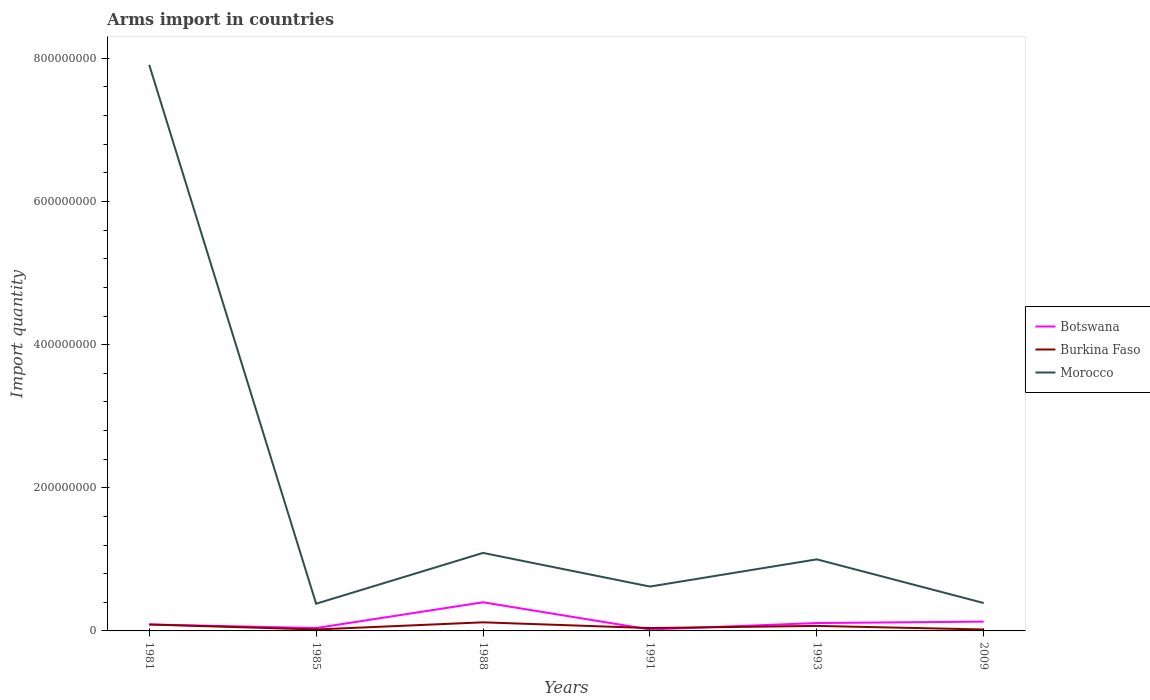How many different coloured lines are there?
Your answer should be very brief. 3. Across all years, what is the maximum total arms import in Botswana?
Keep it short and to the point. 2.00e+06. Is the total arms import in Morocco strictly greater than the total arms import in Botswana over the years?
Provide a short and direct response. No. How many lines are there?
Provide a succinct answer. 3. How many years are there in the graph?
Offer a terse response. 6. What is the difference between two consecutive major ticks on the Y-axis?
Offer a terse response. 2.00e+08. Where does the legend appear in the graph?
Offer a terse response. Center right. What is the title of the graph?
Your answer should be very brief. Arms import in countries. Does "Congo (Republic)" appear as one of the legend labels in the graph?
Give a very brief answer. No. What is the label or title of the Y-axis?
Keep it short and to the point. Import quantity. What is the Import quantity of Botswana in 1981?
Your answer should be very brief. 9.00e+06. What is the Import quantity in Burkina Faso in 1981?
Your answer should be compact. 9.00e+06. What is the Import quantity of Morocco in 1981?
Your answer should be compact. 7.91e+08. What is the Import quantity of Burkina Faso in 1985?
Provide a succinct answer. 2.00e+06. What is the Import quantity in Morocco in 1985?
Ensure brevity in your answer.  3.80e+07. What is the Import quantity of Botswana in 1988?
Your answer should be very brief. 4.00e+07. What is the Import quantity in Burkina Faso in 1988?
Give a very brief answer. 1.20e+07. What is the Import quantity in Morocco in 1988?
Provide a short and direct response. 1.09e+08. What is the Import quantity in Botswana in 1991?
Provide a succinct answer. 2.00e+06. What is the Import quantity in Burkina Faso in 1991?
Keep it short and to the point. 4.00e+06. What is the Import quantity in Morocco in 1991?
Your answer should be compact. 6.20e+07. What is the Import quantity in Botswana in 1993?
Give a very brief answer. 1.10e+07. What is the Import quantity of Burkina Faso in 1993?
Make the answer very short. 7.00e+06. What is the Import quantity in Morocco in 1993?
Provide a succinct answer. 1.00e+08. What is the Import quantity of Botswana in 2009?
Your response must be concise. 1.30e+07. What is the Import quantity in Burkina Faso in 2009?
Your response must be concise. 2.00e+06. What is the Import quantity in Morocco in 2009?
Your answer should be very brief. 3.90e+07. Across all years, what is the maximum Import quantity of Botswana?
Your answer should be very brief. 4.00e+07. Across all years, what is the maximum Import quantity of Morocco?
Offer a very short reply. 7.91e+08. Across all years, what is the minimum Import quantity in Botswana?
Keep it short and to the point. 2.00e+06. Across all years, what is the minimum Import quantity of Burkina Faso?
Offer a terse response. 2.00e+06. Across all years, what is the minimum Import quantity of Morocco?
Your response must be concise. 3.80e+07. What is the total Import quantity of Botswana in the graph?
Make the answer very short. 7.90e+07. What is the total Import quantity in Burkina Faso in the graph?
Make the answer very short. 3.60e+07. What is the total Import quantity of Morocco in the graph?
Provide a short and direct response. 1.14e+09. What is the difference between the Import quantity in Botswana in 1981 and that in 1985?
Ensure brevity in your answer.  5.00e+06. What is the difference between the Import quantity of Burkina Faso in 1981 and that in 1985?
Provide a short and direct response. 7.00e+06. What is the difference between the Import quantity in Morocco in 1981 and that in 1985?
Your answer should be compact. 7.53e+08. What is the difference between the Import quantity in Botswana in 1981 and that in 1988?
Your response must be concise. -3.10e+07. What is the difference between the Import quantity in Morocco in 1981 and that in 1988?
Provide a succinct answer. 6.82e+08. What is the difference between the Import quantity of Botswana in 1981 and that in 1991?
Your response must be concise. 7.00e+06. What is the difference between the Import quantity of Burkina Faso in 1981 and that in 1991?
Offer a terse response. 5.00e+06. What is the difference between the Import quantity in Morocco in 1981 and that in 1991?
Offer a very short reply. 7.29e+08. What is the difference between the Import quantity in Botswana in 1981 and that in 1993?
Give a very brief answer. -2.00e+06. What is the difference between the Import quantity of Morocco in 1981 and that in 1993?
Keep it short and to the point. 6.91e+08. What is the difference between the Import quantity in Burkina Faso in 1981 and that in 2009?
Your response must be concise. 7.00e+06. What is the difference between the Import quantity of Morocco in 1981 and that in 2009?
Keep it short and to the point. 7.52e+08. What is the difference between the Import quantity of Botswana in 1985 and that in 1988?
Ensure brevity in your answer.  -3.60e+07. What is the difference between the Import quantity of Burkina Faso in 1985 and that in 1988?
Offer a very short reply. -1.00e+07. What is the difference between the Import quantity in Morocco in 1985 and that in 1988?
Keep it short and to the point. -7.10e+07. What is the difference between the Import quantity of Botswana in 1985 and that in 1991?
Your response must be concise. 2.00e+06. What is the difference between the Import quantity of Burkina Faso in 1985 and that in 1991?
Your response must be concise. -2.00e+06. What is the difference between the Import quantity in Morocco in 1985 and that in 1991?
Your answer should be very brief. -2.40e+07. What is the difference between the Import quantity in Botswana in 1985 and that in 1993?
Provide a short and direct response. -7.00e+06. What is the difference between the Import quantity of Burkina Faso in 1985 and that in 1993?
Your answer should be compact. -5.00e+06. What is the difference between the Import quantity in Morocco in 1985 and that in 1993?
Give a very brief answer. -6.20e+07. What is the difference between the Import quantity of Botswana in 1985 and that in 2009?
Offer a terse response. -9.00e+06. What is the difference between the Import quantity of Morocco in 1985 and that in 2009?
Ensure brevity in your answer.  -1.00e+06. What is the difference between the Import quantity in Botswana in 1988 and that in 1991?
Make the answer very short. 3.80e+07. What is the difference between the Import quantity of Morocco in 1988 and that in 1991?
Offer a terse response. 4.70e+07. What is the difference between the Import quantity in Botswana in 1988 and that in 1993?
Your response must be concise. 2.90e+07. What is the difference between the Import quantity of Burkina Faso in 1988 and that in 1993?
Provide a short and direct response. 5.00e+06. What is the difference between the Import quantity in Morocco in 1988 and that in 1993?
Ensure brevity in your answer.  9.00e+06. What is the difference between the Import quantity of Botswana in 1988 and that in 2009?
Your answer should be compact. 2.70e+07. What is the difference between the Import quantity of Burkina Faso in 1988 and that in 2009?
Your response must be concise. 1.00e+07. What is the difference between the Import quantity of Morocco in 1988 and that in 2009?
Make the answer very short. 7.00e+07. What is the difference between the Import quantity of Botswana in 1991 and that in 1993?
Your response must be concise. -9.00e+06. What is the difference between the Import quantity of Morocco in 1991 and that in 1993?
Your response must be concise. -3.80e+07. What is the difference between the Import quantity in Botswana in 1991 and that in 2009?
Your response must be concise. -1.10e+07. What is the difference between the Import quantity in Burkina Faso in 1991 and that in 2009?
Provide a short and direct response. 2.00e+06. What is the difference between the Import quantity of Morocco in 1991 and that in 2009?
Your answer should be compact. 2.30e+07. What is the difference between the Import quantity of Burkina Faso in 1993 and that in 2009?
Your answer should be compact. 5.00e+06. What is the difference between the Import quantity of Morocco in 1993 and that in 2009?
Keep it short and to the point. 6.10e+07. What is the difference between the Import quantity in Botswana in 1981 and the Import quantity in Burkina Faso in 1985?
Keep it short and to the point. 7.00e+06. What is the difference between the Import quantity in Botswana in 1981 and the Import quantity in Morocco in 1985?
Your answer should be compact. -2.90e+07. What is the difference between the Import quantity in Burkina Faso in 1981 and the Import quantity in Morocco in 1985?
Provide a succinct answer. -2.90e+07. What is the difference between the Import quantity in Botswana in 1981 and the Import quantity in Burkina Faso in 1988?
Give a very brief answer. -3.00e+06. What is the difference between the Import quantity of Botswana in 1981 and the Import quantity of Morocco in 1988?
Provide a short and direct response. -1.00e+08. What is the difference between the Import quantity of Burkina Faso in 1981 and the Import quantity of Morocco in 1988?
Your answer should be very brief. -1.00e+08. What is the difference between the Import quantity of Botswana in 1981 and the Import quantity of Burkina Faso in 1991?
Your answer should be very brief. 5.00e+06. What is the difference between the Import quantity in Botswana in 1981 and the Import quantity in Morocco in 1991?
Give a very brief answer. -5.30e+07. What is the difference between the Import quantity of Burkina Faso in 1981 and the Import quantity of Morocco in 1991?
Keep it short and to the point. -5.30e+07. What is the difference between the Import quantity in Botswana in 1981 and the Import quantity in Morocco in 1993?
Offer a terse response. -9.10e+07. What is the difference between the Import quantity of Burkina Faso in 1981 and the Import quantity of Morocco in 1993?
Give a very brief answer. -9.10e+07. What is the difference between the Import quantity in Botswana in 1981 and the Import quantity in Burkina Faso in 2009?
Offer a terse response. 7.00e+06. What is the difference between the Import quantity in Botswana in 1981 and the Import quantity in Morocco in 2009?
Provide a succinct answer. -3.00e+07. What is the difference between the Import quantity of Burkina Faso in 1981 and the Import quantity of Morocco in 2009?
Your answer should be compact. -3.00e+07. What is the difference between the Import quantity in Botswana in 1985 and the Import quantity in Burkina Faso in 1988?
Keep it short and to the point. -8.00e+06. What is the difference between the Import quantity of Botswana in 1985 and the Import quantity of Morocco in 1988?
Your answer should be compact. -1.05e+08. What is the difference between the Import quantity in Burkina Faso in 1985 and the Import quantity in Morocco in 1988?
Offer a very short reply. -1.07e+08. What is the difference between the Import quantity of Botswana in 1985 and the Import quantity of Morocco in 1991?
Keep it short and to the point. -5.80e+07. What is the difference between the Import quantity of Burkina Faso in 1985 and the Import quantity of Morocco in 1991?
Ensure brevity in your answer.  -6.00e+07. What is the difference between the Import quantity of Botswana in 1985 and the Import quantity of Morocco in 1993?
Give a very brief answer. -9.60e+07. What is the difference between the Import quantity of Burkina Faso in 1985 and the Import quantity of Morocco in 1993?
Offer a very short reply. -9.80e+07. What is the difference between the Import quantity in Botswana in 1985 and the Import quantity in Morocco in 2009?
Your response must be concise. -3.50e+07. What is the difference between the Import quantity of Burkina Faso in 1985 and the Import quantity of Morocco in 2009?
Give a very brief answer. -3.70e+07. What is the difference between the Import quantity in Botswana in 1988 and the Import quantity in Burkina Faso in 1991?
Provide a short and direct response. 3.60e+07. What is the difference between the Import quantity of Botswana in 1988 and the Import quantity of Morocco in 1991?
Provide a short and direct response. -2.20e+07. What is the difference between the Import quantity of Burkina Faso in 1988 and the Import quantity of Morocco in 1991?
Offer a very short reply. -5.00e+07. What is the difference between the Import quantity of Botswana in 1988 and the Import quantity of Burkina Faso in 1993?
Provide a short and direct response. 3.30e+07. What is the difference between the Import quantity in Botswana in 1988 and the Import quantity in Morocco in 1993?
Offer a terse response. -6.00e+07. What is the difference between the Import quantity of Burkina Faso in 1988 and the Import quantity of Morocco in 1993?
Keep it short and to the point. -8.80e+07. What is the difference between the Import quantity of Botswana in 1988 and the Import quantity of Burkina Faso in 2009?
Provide a succinct answer. 3.80e+07. What is the difference between the Import quantity in Botswana in 1988 and the Import quantity in Morocco in 2009?
Your answer should be compact. 1.00e+06. What is the difference between the Import quantity of Burkina Faso in 1988 and the Import quantity of Morocco in 2009?
Your response must be concise. -2.70e+07. What is the difference between the Import quantity in Botswana in 1991 and the Import quantity in Burkina Faso in 1993?
Your answer should be compact. -5.00e+06. What is the difference between the Import quantity of Botswana in 1991 and the Import quantity of Morocco in 1993?
Give a very brief answer. -9.80e+07. What is the difference between the Import quantity in Burkina Faso in 1991 and the Import quantity in Morocco in 1993?
Make the answer very short. -9.60e+07. What is the difference between the Import quantity in Botswana in 1991 and the Import quantity in Morocco in 2009?
Provide a short and direct response. -3.70e+07. What is the difference between the Import quantity in Burkina Faso in 1991 and the Import quantity in Morocco in 2009?
Ensure brevity in your answer.  -3.50e+07. What is the difference between the Import quantity in Botswana in 1993 and the Import quantity in Burkina Faso in 2009?
Your answer should be very brief. 9.00e+06. What is the difference between the Import quantity in Botswana in 1993 and the Import quantity in Morocco in 2009?
Your answer should be very brief. -2.80e+07. What is the difference between the Import quantity in Burkina Faso in 1993 and the Import quantity in Morocco in 2009?
Your answer should be very brief. -3.20e+07. What is the average Import quantity in Botswana per year?
Your answer should be compact. 1.32e+07. What is the average Import quantity in Morocco per year?
Make the answer very short. 1.90e+08. In the year 1981, what is the difference between the Import quantity of Botswana and Import quantity of Burkina Faso?
Make the answer very short. 0. In the year 1981, what is the difference between the Import quantity in Botswana and Import quantity in Morocco?
Provide a succinct answer. -7.82e+08. In the year 1981, what is the difference between the Import quantity in Burkina Faso and Import quantity in Morocco?
Give a very brief answer. -7.82e+08. In the year 1985, what is the difference between the Import quantity of Botswana and Import quantity of Burkina Faso?
Ensure brevity in your answer.  2.00e+06. In the year 1985, what is the difference between the Import quantity in Botswana and Import quantity in Morocco?
Your answer should be very brief. -3.40e+07. In the year 1985, what is the difference between the Import quantity of Burkina Faso and Import quantity of Morocco?
Provide a succinct answer. -3.60e+07. In the year 1988, what is the difference between the Import quantity of Botswana and Import quantity of Burkina Faso?
Make the answer very short. 2.80e+07. In the year 1988, what is the difference between the Import quantity of Botswana and Import quantity of Morocco?
Provide a succinct answer. -6.90e+07. In the year 1988, what is the difference between the Import quantity of Burkina Faso and Import quantity of Morocco?
Make the answer very short. -9.70e+07. In the year 1991, what is the difference between the Import quantity in Botswana and Import quantity in Morocco?
Your response must be concise. -6.00e+07. In the year 1991, what is the difference between the Import quantity in Burkina Faso and Import quantity in Morocco?
Make the answer very short. -5.80e+07. In the year 1993, what is the difference between the Import quantity of Botswana and Import quantity of Burkina Faso?
Provide a short and direct response. 4.00e+06. In the year 1993, what is the difference between the Import quantity in Botswana and Import quantity in Morocco?
Your response must be concise. -8.90e+07. In the year 1993, what is the difference between the Import quantity in Burkina Faso and Import quantity in Morocco?
Give a very brief answer. -9.30e+07. In the year 2009, what is the difference between the Import quantity in Botswana and Import quantity in Burkina Faso?
Provide a succinct answer. 1.10e+07. In the year 2009, what is the difference between the Import quantity in Botswana and Import quantity in Morocco?
Provide a succinct answer. -2.60e+07. In the year 2009, what is the difference between the Import quantity in Burkina Faso and Import quantity in Morocco?
Ensure brevity in your answer.  -3.70e+07. What is the ratio of the Import quantity of Botswana in 1981 to that in 1985?
Provide a short and direct response. 2.25. What is the ratio of the Import quantity in Burkina Faso in 1981 to that in 1985?
Make the answer very short. 4.5. What is the ratio of the Import quantity of Morocco in 1981 to that in 1985?
Keep it short and to the point. 20.82. What is the ratio of the Import quantity in Botswana in 1981 to that in 1988?
Ensure brevity in your answer.  0.23. What is the ratio of the Import quantity in Morocco in 1981 to that in 1988?
Provide a succinct answer. 7.26. What is the ratio of the Import quantity of Burkina Faso in 1981 to that in 1991?
Your answer should be compact. 2.25. What is the ratio of the Import quantity in Morocco in 1981 to that in 1991?
Make the answer very short. 12.76. What is the ratio of the Import quantity of Botswana in 1981 to that in 1993?
Your answer should be very brief. 0.82. What is the ratio of the Import quantity of Burkina Faso in 1981 to that in 1993?
Your answer should be very brief. 1.29. What is the ratio of the Import quantity in Morocco in 1981 to that in 1993?
Your response must be concise. 7.91. What is the ratio of the Import quantity in Botswana in 1981 to that in 2009?
Offer a terse response. 0.69. What is the ratio of the Import quantity in Morocco in 1981 to that in 2009?
Give a very brief answer. 20.28. What is the ratio of the Import quantity in Burkina Faso in 1985 to that in 1988?
Give a very brief answer. 0.17. What is the ratio of the Import quantity of Morocco in 1985 to that in 1988?
Your answer should be compact. 0.35. What is the ratio of the Import quantity in Botswana in 1985 to that in 1991?
Your answer should be compact. 2. What is the ratio of the Import quantity of Morocco in 1985 to that in 1991?
Offer a terse response. 0.61. What is the ratio of the Import quantity of Botswana in 1985 to that in 1993?
Give a very brief answer. 0.36. What is the ratio of the Import quantity in Burkina Faso in 1985 to that in 1993?
Keep it short and to the point. 0.29. What is the ratio of the Import quantity in Morocco in 1985 to that in 1993?
Ensure brevity in your answer.  0.38. What is the ratio of the Import quantity of Botswana in 1985 to that in 2009?
Your answer should be very brief. 0.31. What is the ratio of the Import quantity in Burkina Faso in 1985 to that in 2009?
Make the answer very short. 1. What is the ratio of the Import quantity in Morocco in 1985 to that in 2009?
Ensure brevity in your answer.  0.97. What is the ratio of the Import quantity in Burkina Faso in 1988 to that in 1991?
Offer a very short reply. 3. What is the ratio of the Import quantity in Morocco in 1988 to that in 1991?
Make the answer very short. 1.76. What is the ratio of the Import quantity in Botswana in 1988 to that in 1993?
Give a very brief answer. 3.64. What is the ratio of the Import quantity of Burkina Faso in 1988 to that in 1993?
Your response must be concise. 1.71. What is the ratio of the Import quantity in Morocco in 1988 to that in 1993?
Provide a short and direct response. 1.09. What is the ratio of the Import quantity in Botswana in 1988 to that in 2009?
Keep it short and to the point. 3.08. What is the ratio of the Import quantity in Burkina Faso in 1988 to that in 2009?
Give a very brief answer. 6. What is the ratio of the Import quantity in Morocco in 1988 to that in 2009?
Provide a succinct answer. 2.79. What is the ratio of the Import quantity of Botswana in 1991 to that in 1993?
Give a very brief answer. 0.18. What is the ratio of the Import quantity of Burkina Faso in 1991 to that in 1993?
Offer a very short reply. 0.57. What is the ratio of the Import quantity of Morocco in 1991 to that in 1993?
Give a very brief answer. 0.62. What is the ratio of the Import quantity of Botswana in 1991 to that in 2009?
Offer a terse response. 0.15. What is the ratio of the Import quantity in Burkina Faso in 1991 to that in 2009?
Your answer should be very brief. 2. What is the ratio of the Import quantity of Morocco in 1991 to that in 2009?
Make the answer very short. 1.59. What is the ratio of the Import quantity in Botswana in 1993 to that in 2009?
Provide a short and direct response. 0.85. What is the ratio of the Import quantity of Morocco in 1993 to that in 2009?
Ensure brevity in your answer.  2.56. What is the difference between the highest and the second highest Import quantity in Botswana?
Your response must be concise. 2.70e+07. What is the difference between the highest and the second highest Import quantity in Burkina Faso?
Provide a short and direct response. 3.00e+06. What is the difference between the highest and the second highest Import quantity in Morocco?
Your answer should be very brief. 6.82e+08. What is the difference between the highest and the lowest Import quantity of Botswana?
Your answer should be compact. 3.80e+07. What is the difference between the highest and the lowest Import quantity of Burkina Faso?
Make the answer very short. 1.00e+07. What is the difference between the highest and the lowest Import quantity in Morocco?
Offer a very short reply. 7.53e+08. 